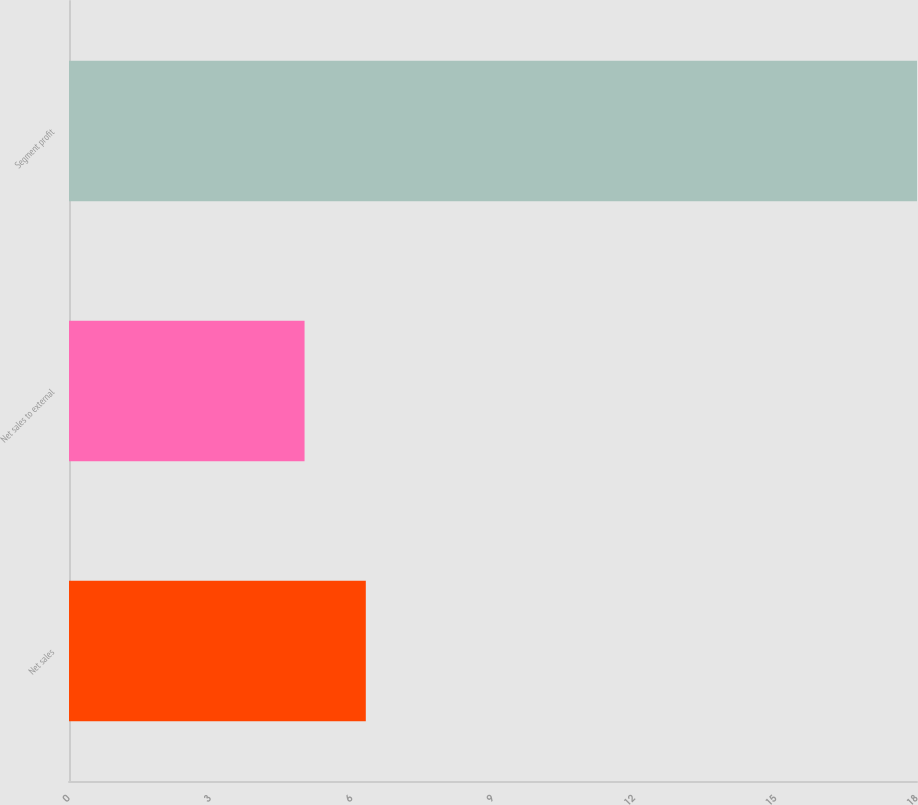Convert chart to OTSL. <chart><loc_0><loc_0><loc_500><loc_500><bar_chart><fcel>Net sales<fcel>Net sales to external<fcel>Segment profit<nl><fcel>6.3<fcel>5<fcel>18<nl></chart> 